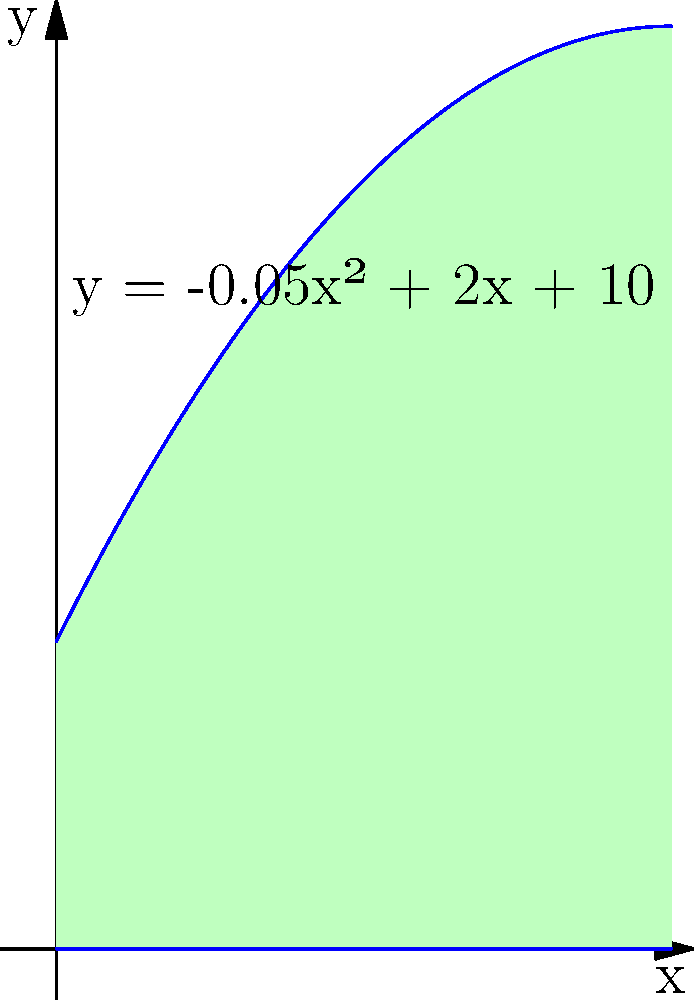As an archaeologist studying the architectural remains of an ancient stadium, you've uncovered the foundation of a semi-circular end zone. The outline of this foundation can be modeled by the polynomial function $y = -0.05x^2 + 2x + 10$ for $0 \leq x \leq 20$ (measured in meters). Calculate the area enclosed by this curve and the x-axis, which represents the total area of this section of the stadium. To find the area enclosed by the curve and the x-axis, we need to integrate the function over the given interval. Here's how we can do it step-by-step:

1) The area is given by the definite integral:

   $$A = \int_0^{20} (-0.05x^2 + 2x + 10) dx$$

2) Integrate each term:
   $$A = [-0.05 \cdot \frac{x^3}{3} + 2 \cdot \frac{x^2}{2} + 10x]_0^{20}$$

3) Evaluate at the upper and lower bounds:
   $$A = [-0.05 \cdot \frac{20^3}{3} + 2 \cdot \frac{20^2}{2} + 10 \cdot 20] - [-0.05 \cdot \frac{0^3}{3} + 2 \cdot \frac{0^2}{2} + 10 \cdot 0]$$

4) Simplify:
   $$A = [-133.33 + 400 + 200] - [0]$$
   $$A = 466.67$$

5) Round to two decimal places:
   $$A \approx 466.67 \text{ square meters}$$

Therefore, the area enclosed by the curve representing the stadium's foundation and the x-axis is approximately 466.67 square meters.
Answer: 466.67 square meters 